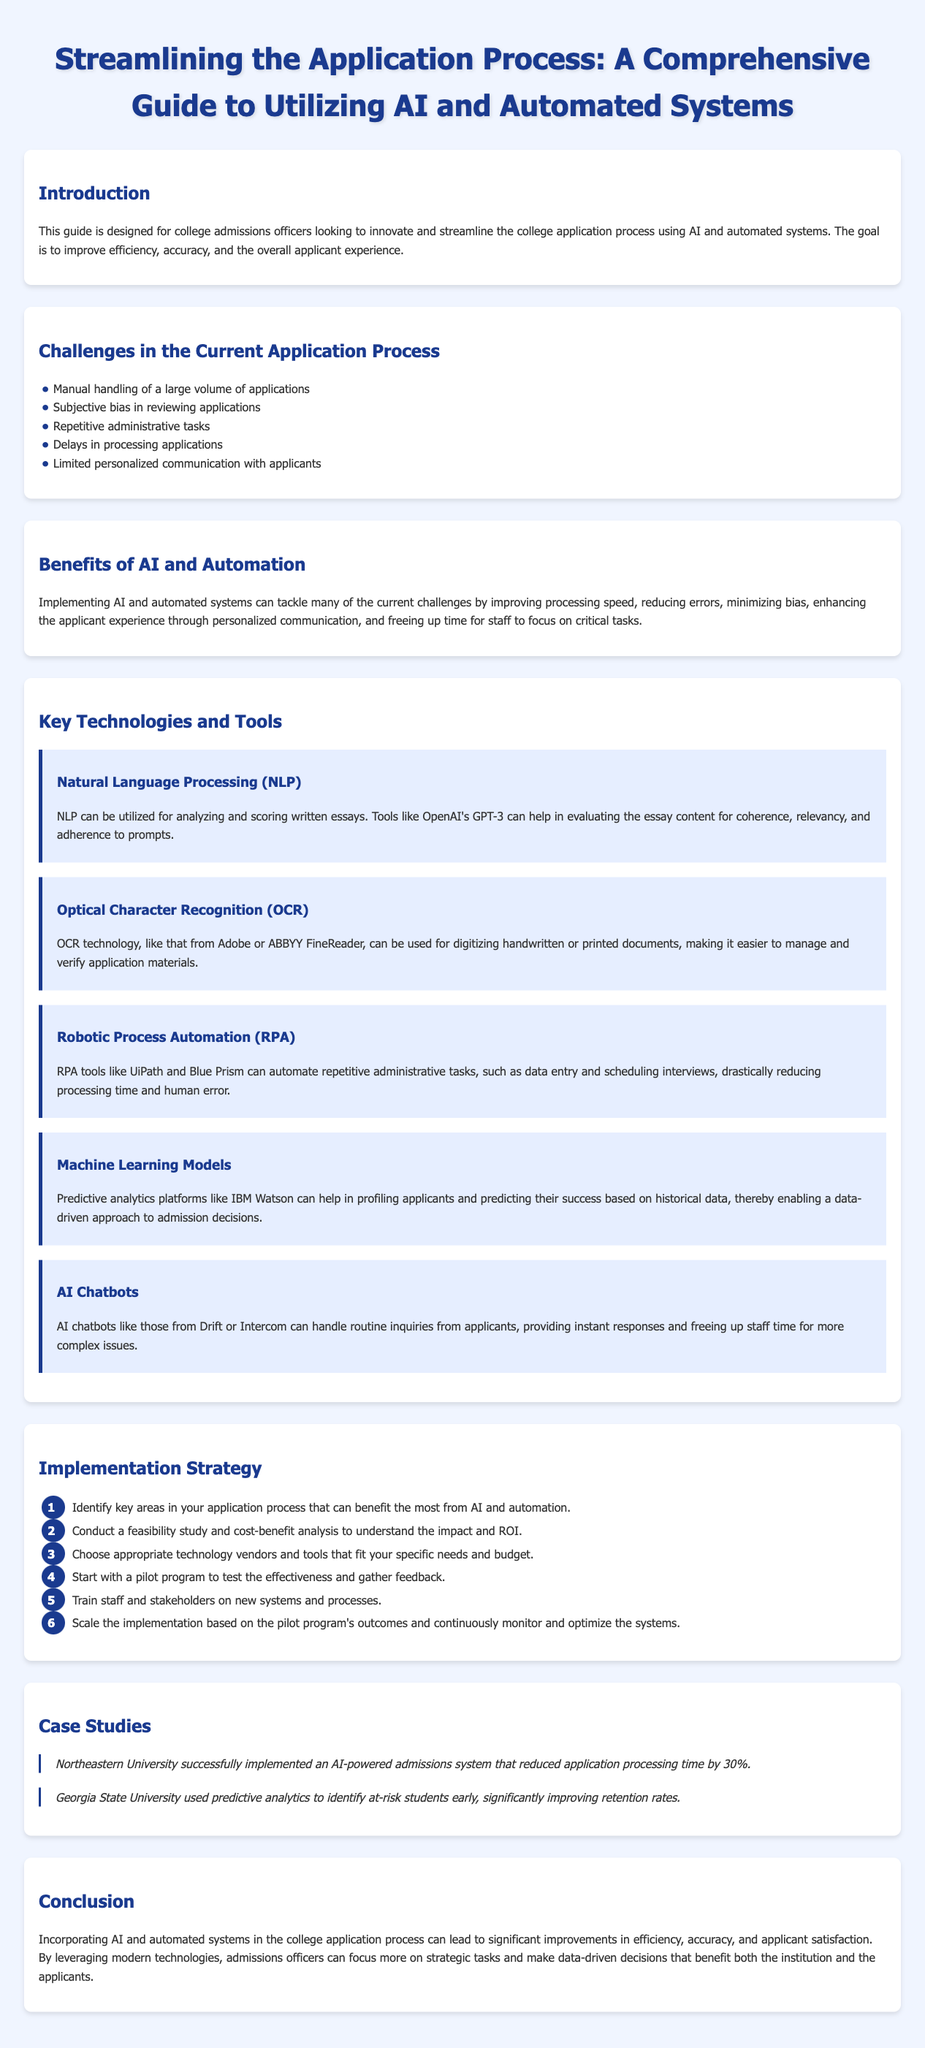What are the main challenges in the current application process? The document lists challenges such as manual handling of a large volume of applications, subjective bias in reviewing applications, and delays in processing applications.
Answer: five challenges What technology can automate repetitive administrative tasks? Robotic Process Automation tools like UiPath and Blue Prism are mentioned for automating tasks like data entry and scheduling.
Answer: RPA What is the purpose of Natural Language Processing in the application process? NLP is utilized for analyzing and scoring written essays, helping to evaluate content coherence, relevancy, and adherence to prompts.
Answer: essay evaluation Which university implemented an AI-powered admissions system that reduced processing time? The document states that Northeastern University successfully implemented the system and saw a 30% reduction in processing time.
Answer: Northeastern University How many steps are in the implementation strategy? The implementation strategy consists of six steps outlined in the document.
Answer: six steps What is one benefit of using AI and automation according to the guide? One benefit highlighted is improving processing speed and reducing errors in the application process.
Answer: processing speed What tool can digitize handwritten or printed documents? The guide mentions Optical Character Recognition technology can be used for digitizing such documents.
Answer: OCR technology What should be assessed before choosing technology vendors for AI implementation? A feasibility study and cost-benefit analysis should be conducted to understand impact and ROI.
Answer: feasibility study What does the case study of Georgia State University focus on? The case study highlights the use of predictive analytics to identify at-risk students and improve retention rates.
Answer: predictive analytics 